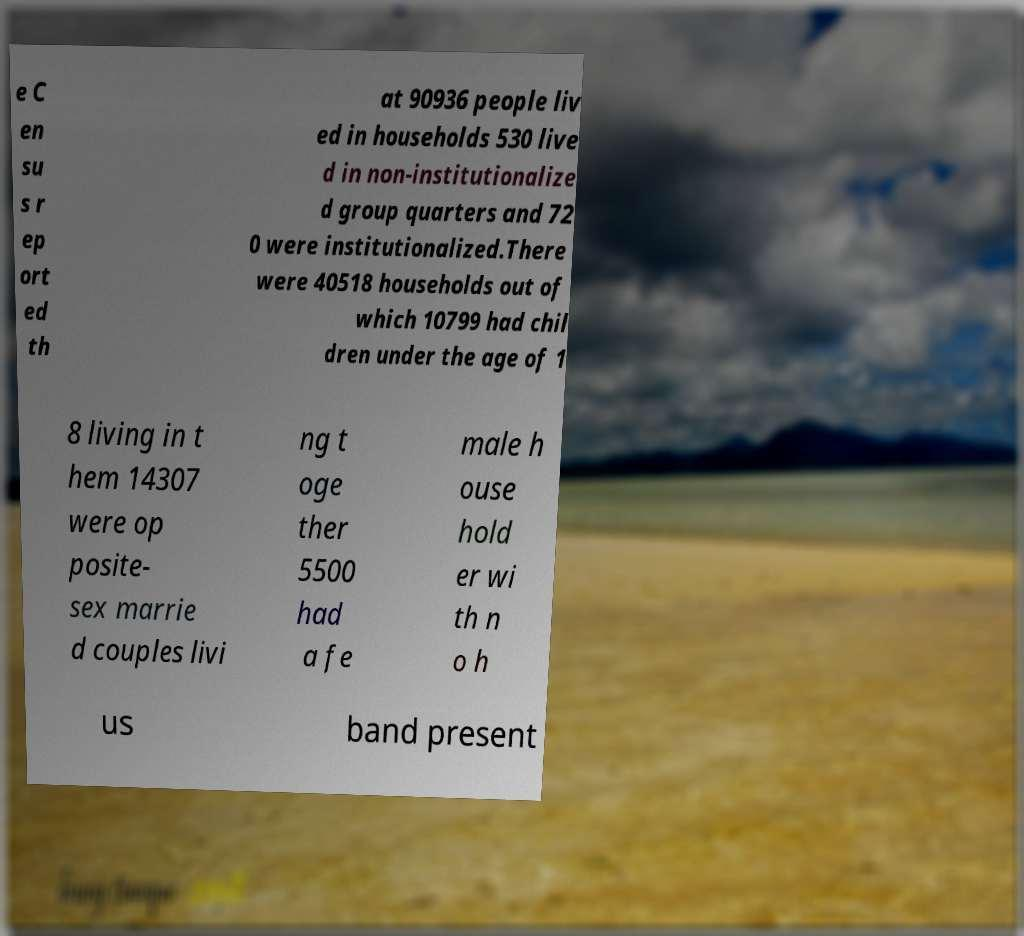Can you read and provide the text displayed in the image?This photo seems to have some interesting text. Can you extract and type it out for me? e C en su s r ep ort ed th at 90936 people liv ed in households 530 live d in non-institutionalize d group quarters and 72 0 were institutionalized.There were 40518 households out of which 10799 had chil dren under the age of 1 8 living in t hem 14307 were op posite- sex marrie d couples livi ng t oge ther 5500 had a fe male h ouse hold er wi th n o h us band present 